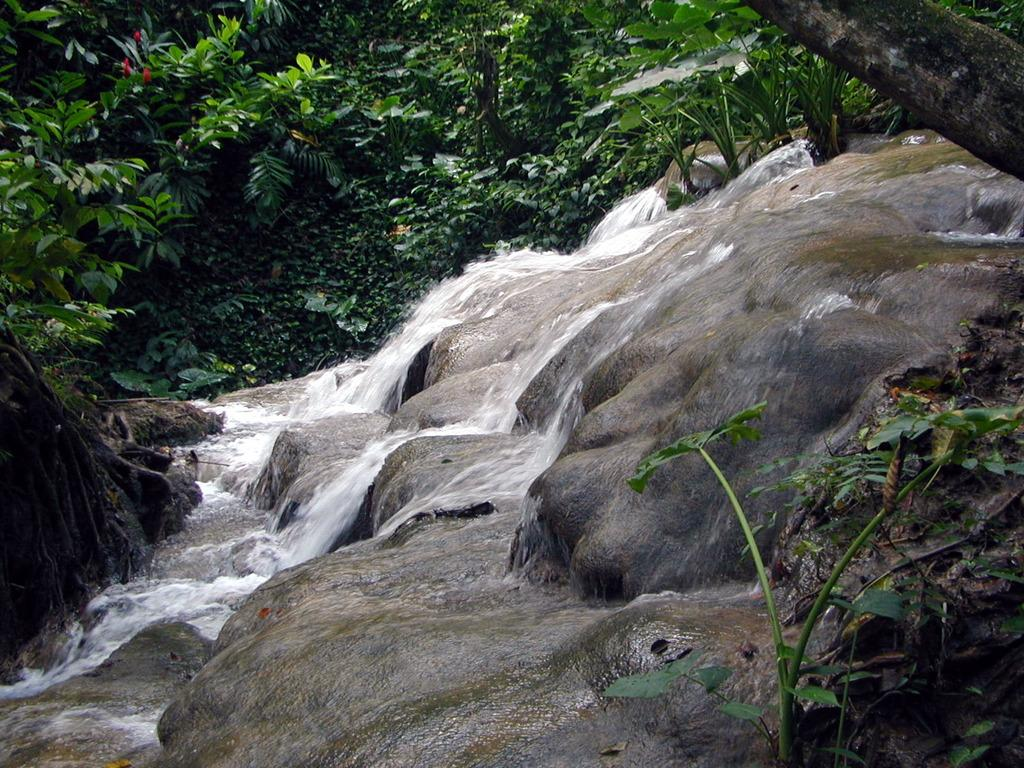What is the main subject in the center of the image? There is water in the center of the image. What can be seen in the background of the image? There are trees in the background of the image. How many lizards are sitting on the car in the image? There is no car or lizards present in the image; it features water and trees. 